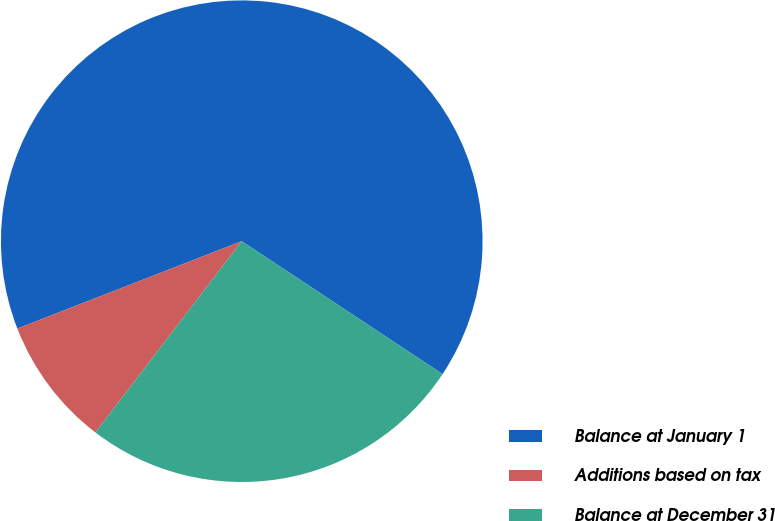Convert chart to OTSL. <chart><loc_0><loc_0><loc_500><loc_500><pie_chart><fcel>Balance at January 1<fcel>Additions based on tax<fcel>Balance at December 31<nl><fcel>65.22%<fcel>8.7%<fcel>26.09%<nl></chart> 